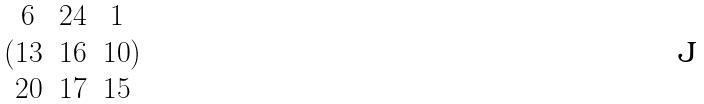<formula> <loc_0><loc_0><loc_500><loc_500>( \begin{matrix} 6 & 2 4 & 1 \\ 1 3 & 1 6 & 1 0 \\ 2 0 & 1 7 & 1 5 \end{matrix} )</formula> 